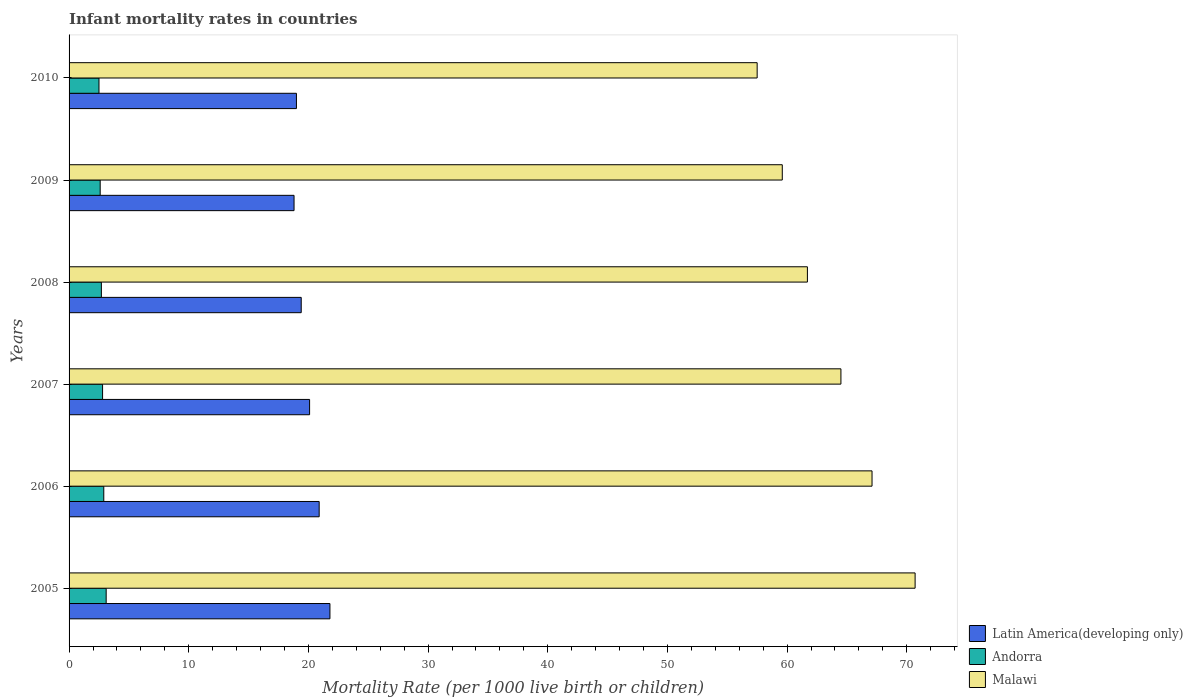Are the number of bars per tick equal to the number of legend labels?
Offer a terse response. Yes. How many bars are there on the 2nd tick from the top?
Your answer should be compact. 3. What is the label of the 5th group of bars from the top?
Offer a terse response. 2006. Across all years, what is the maximum infant mortality rate in Malawi?
Keep it short and to the point. 70.7. Across all years, what is the minimum infant mortality rate in Malawi?
Keep it short and to the point. 57.5. In which year was the infant mortality rate in Latin America(developing only) maximum?
Keep it short and to the point. 2005. In which year was the infant mortality rate in Malawi minimum?
Ensure brevity in your answer.  2010. What is the total infant mortality rate in Latin America(developing only) in the graph?
Your response must be concise. 120. What is the difference between the infant mortality rate in Malawi in 2006 and that in 2008?
Ensure brevity in your answer.  5.4. What is the difference between the infant mortality rate in Latin America(developing only) in 2006 and the infant mortality rate in Andorra in 2010?
Your response must be concise. 18.4. What is the average infant mortality rate in Malawi per year?
Your response must be concise. 63.52. In the year 2005, what is the difference between the infant mortality rate in Latin America(developing only) and infant mortality rate in Andorra?
Offer a very short reply. 18.7. Is the infant mortality rate in Andorra in 2007 less than that in 2009?
Your response must be concise. No. Is the difference between the infant mortality rate in Latin America(developing only) in 2005 and 2007 greater than the difference between the infant mortality rate in Andorra in 2005 and 2007?
Your answer should be compact. Yes. What is the difference between the highest and the second highest infant mortality rate in Latin America(developing only)?
Ensure brevity in your answer.  0.9. What is the difference between the highest and the lowest infant mortality rate in Malawi?
Provide a short and direct response. 13.2. Is the sum of the infant mortality rate in Malawi in 2006 and 2007 greater than the maximum infant mortality rate in Latin America(developing only) across all years?
Ensure brevity in your answer.  Yes. What does the 3rd bar from the top in 2005 represents?
Keep it short and to the point. Latin America(developing only). What does the 3rd bar from the bottom in 2010 represents?
Your answer should be very brief. Malawi. How many bars are there?
Your answer should be very brief. 18. Are all the bars in the graph horizontal?
Offer a very short reply. Yes. How many years are there in the graph?
Offer a very short reply. 6. Where does the legend appear in the graph?
Provide a succinct answer. Bottom right. How are the legend labels stacked?
Ensure brevity in your answer.  Vertical. What is the title of the graph?
Give a very brief answer. Infant mortality rates in countries. What is the label or title of the X-axis?
Offer a very short reply. Mortality Rate (per 1000 live birth or children). What is the label or title of the Y-axis?
Your response must be concise. Years. What is the Mortality Rate (per 1000 live birth or children) in Latin America(developing only) in 2005?
Make the answer very short. 21.8. What is the Mortality Rate (per 1000 live birth or children) in Andorra in 2005?
Keep it short and to the point. 3.1. What is the Mortality Rate (per 1000 live birth or children) of Malawi in 2005?
Ensure brevity in your answer.  70.7. What is the Mortality Rate (per 1000 live birth or children) of Latin America(developing only) in 2006?
Your answer should be very brief. 20.9. What is the Mortality Rate (per 1000 live birth or children) of Andorra in 2006?
Ensure brevity in your answer.  2.9. What is the Mortality Rate (per 1000 live birth or children) of Malawi in 2006?
Provide a succinct answer. 67.1. What is the Mortality Rate (per 1000 live birth or children) in Latin America(developing only) in 2007?
Provide a succinct answer. 20.1. What is the Mortality Rate (per 1000 live birth or children) of Andorra in 2007?
Your answer should be compact. 2.8. What is the Mortality Rate (per 1000 live birth or children) in Malawi in 2007?
Your answer should be very brief. 64.5. What is the Mortality Rate (per 1000 live birth or children) in Malawi in 2008?
Offer a very short reply. 61.7. What is the Mortality Rate (per 1000 live birth or children) in Latin America(developing only) in 2009?
Provide a succinct answer. 18.8. What is the Mortality Rate (per 1000 live birth or children) in Malawi in 2009?
Give a very brief answer. 59.6. What is the Mortality Rate (per 1000 live birth or children) in Latin America(developing only) in 2010?
Offer a terse response. 19. What is the Mortality Rate (per 1000 live birth or children) in Malawi in 2010?
Provide a short and direct response. 57.5. Across all years, what is the maximum Mortality Rate (per 1000 live birth or children) of Latin America(developing only)?
Provide a succinct answer. 21.8. Across all years, what is the maximum Mortality Rate (per 1000 live birth or children) in Malawi?
Give a very brief answer. 70.7. Across all years, what is the minimum Mortality Rate (per 1000 live birth or children) of Malawi?
Your answer should be very brief. 57.5. What is the total Mortality Rate (per 1000 live birth or children) in Latin America(developing only) in the graph?
Your answer should be compact. 120. What is the total Mortality Rate (per 1000 live birth or children) of Malawi in the graph?
Provide a short and direct response. 381.1. What is the difference between the Mortality Rate (per 1000 live birth or children) of Andorra in 2005 and that in 2008?
Your response must be concise. 0.4. What is the difference between the Mortality Rate (per 1000 live birth or children) in Andorra in 2005 and that in 2009?
Provide a short and direct response. 0.5. What is the difference between the Mortality Rate (per 1000 live birth or children) of Malawi in 2005 and that in 2009?
Provide a succinct answer. 11.1. What is the difference between the Mortality Rate (per 1000 live birth or children) of Latin America(developing only) in 2005 and that in 2010?
Provide a short and direct response. 2.8. What is the difference between the Mortality Rate (per 1000 live birth or children) in Latin America(developing only) in 2006 and that in 2007?
Ensure brevity in your answer.  0.8. What is the difference between the Mortality Rate (per 1000 live birth or children) in Malawi in 2006 and that in 2007?
Your answer should be very brief. 2.6. What is the difference between the Mortality Rate (per 1000 live birth or children) of Andorra in 2006 and that in 2009?
Your response must be concise. 0.3. What is the difference between the Mortality Rate (per 1000 live birth or children) of Malawi in 2006 and that in 2010?
Give a very brief answer. 9.6. What is the difference between the Mortality Rate (per 1000 live birth or children) of Latin America(developing only) in 2007 and that in 2008?
Offer a terse response. 0.7. What is the difference between the Mortality Rate (per 1000 live birth or children) in Andorra in 2007 and that in 2008?
Your answer should be very brief. 0.1. What is the difference between the Mortality Rate (per 1000 live birth or children) of Malawi in 2007 and that in 2008?
Your response must be concise. 2.8. What is the difference between the Mortality Rate (per 1000 live birth or children) in Latin America(developing only) in 2007 and that in 2009?
Provide a short and direct response. 1.3. What is the difference between the Mortality Rate (per 1000 live birth or children) of Andorra in 2007 and that in 2009?
Make the answer very short. 0.2. What is the difference between the Mortality Rate (per 1000 live birth or children) in Latin America(developing only) in 2008 and that in 2009?
Offer a terse response. 0.6. What is the difference between the Mortality Rate (per 1000 live birth or children) of Latin America(developing only) in 2008 and that in 2010?
Ensure brevity in your answer.  0.4. What is the difference between the Mortality Rate (per 1000 live birth or children) of Andorra in 2008 and that in 2010?
Offer a terse response. 0.2. What is the difference between the Mortality Rate (per 1000 live birth or children) in Malawi in 2008 and that in 2010?
Your answer should be compact. 4.2. What is the difference between the Mortality Rate (per 1000 live birth or children) in Latin America(developing only) in 2009 and that in 2010?
Make the answer very short. -0.2. What is the difference between the Mortality Rate (per 1000 live birth or children) in Andorra in 2009 and that in 2010?
Your response must be concise. 0.1. What is the difference between the Mortality Rate (per 1000 live birth or children) of Latin America(developing only) in 2005 and the Mortality Rate (per 1000 live birth or children) of Malawi in 2006?
Ensure brevity in your answer.  -45.3. What is the difference between the Mortality Rate (per 1000 live birth or children) of Andorra in 2005 and the Mortality Rate (per 1000 live birth or children) of Malawi in 2006?
Ensure brevity in your answer.  -64. What is the difference between the Mortality Rate (per 1000 live birth or children) in Latin America(developing only) in 2005 and the Mortality Rate (per 1000 live birth or children) in Andorra in 2007?
Your answer should be very brief. 19. What is the difference between the Mortality Rate (per 1000 live birth or children) in Latin America(developing only) in 2005 and the Mortality Rate (per 1000 live birth or children) in Malawi in 2007?
Ensure brevity in your answer.  -42.7. What is the difference between the Mortality Rate (per 1000 live birth or children) of Andorra in 2005 and the Mortality Rate (per 1000 live birth or children) of Malawi in 2007?
Your response must be concise. -61.4. What is the difference between the Mortality Rate (per 1000 live birth or children) in Latin America(developing only) in 2005 and the Mortality Rate (per 1000 live birth or children) in Andorra in 2008?
Your answer should be compact. 19.1. What is the difference between the Mortality Rate (per 1000 live birth or children) in Latin America(developing only) in 2005 and the Mortality Rate (per 1000 live birth or children) in Malawi in 2008?
Provide a succinct answer. -39.9. What is the difference between the Mortality Rate (per 1000 live birth or children) of Andorra in 2005 and the Mortality Rate (per 1000 live birth or children) of Malawi in 2008?
Your answer should be compact. -58.6. What is the difference between the Mortality Rate (per 1000 live birth or children) of Latin America(developing only) in 2005 and the Mortality Rate (per 1000 live birth or children) of Malawi in 2009?
Ensure brevity in your answer.  -37.8. What is the difference between the Mortality Rate (per 1000 live birth or children) in Andorra in 2005 and the Mortality Rate (per 1000 live birth or children) in Malawi in 2009?
Your response must be concise. -56.5. What is the difference between the Mortality Rate (per 1000 live birth or children) of Latin America(developing only) in 2005 and the Mortality Rate (per 1000 live birth or children) of Andorra in 2010?
Give a very brief answer. 19.3. What is the difference between the Mortality Rate (per 1000 live birth or children) in Latin America(developing only) in 2005 and the Mortality Rate (per 1000 live birth or children) in Malawi in 2010?
Give a very brief answer. -35.7. What is the difference between the Mortality Rate (per 1000 live birth or children) in Andorra in 2005 and the Mortality Rate (per 1000 live birth or children) in Malawi in 2010?
Your answer should be very brief. -54.4. What is the difference between the Mortality Rate (per 1000 live birth or children) in Latin America(developing only) in 2006 and the Mortality Rate (per 1000 live birth or children) in Malawi in 2007?
Keep it short and to the point. -43.6. What is the difference between the Mortality Rate (per 1000 live birth or children) in Andorra in 2006 and the Mortality Rate (per 1000 live birth or children) in Malawi in 2007?
Give a very brief answer. -61.6. What is the difference between the Mortality Rate (per 1000 live birth or children) of Latin America(developing only) in 2006 and the Mortality Rate (per 1000 live birth or children) of Andorra in 2008?
Your answer should be very brief. 18.2. What is the difference between the Mortality Rate (per 1000 live birth or children) in Latin America(developing only) in 2006 and the Mortality Rate (per 1000 live birth or children) in Malawi in 2008?
Provide a short and direct response. -40.8. What is the difference between the Mortality Rate (per 1000 live birth or children) in Andorra in 2006 and the Mortality Rate (per 1000 live birth or children) in Malawi in 2008?
Your response must be concise. -58.8. What is the difference between the Mortality Rate (per 1000 live birth or children) in Latin America(developing only) in 2006 and the Mortality Rate (per 1000 live birth or children) in Andorra in 2009?
Ensure brevity in your answer.  18.3. What is the difference between the Mortality Rate (per 1000 live birth or children) of Latin America(developing only) in 2006 and the Mortality Rate (per 1000 live birth or children) of Malawi in 2009?
Provide a succinct answer. -38.7. What is the difference between the Mortality Rate (per 1000 live birth or children) of Andorra in 2006 and the Mortality Rate (per 1000 live birth or children) of Malawi in 2009?
Offer a very short reply. -56.7. What is the difference between the Mortality Rate (per 1000 live birth or children) in Latin America(developing only) in 2006 and the Mortality Rate (per 1000 live birth or children) in Andorra in 2010?
Keep it short and to the point. 18.4. What is the difference between the Mortality Rate (per 1000 live birth or children) of Latin America(developing only) in 2006 and the Mortality Rate (per 1000 live birth or children) of Malawi in 2010?
Your response must be concise. -36.6. What is the difference between the Mortality Rate (per 1000 live birth or children) in Andorra in 2006 and the Mortality Rate (per 1000 live birth or children) in Malawi in 2010?
Keep it short and to the point. -54.6. What is the difference between the Mortality Rate (per 1000 live birth or children) of Latin America(developing only) in 2007 and the Mortality Rate (per 1000 live birth or children) of Malawi in 2008?
Offer a very short reply. -41.6. What is the difference between the Mortality Rate (per 1000 live birth or children) in Andorra in 2007 and the Mortality Rate (per 1000 live birth or children) in Malawi in 2008?
Make the answer very short. -58.9. What is the difference between the Mortality Rate (per 1000 live birth or children) of Latin America(developing only) in 2007 and the Mortality Rate (per 1000 live birth or children) of Malawi in 2009?
Your answer should be very brief. -39.5. What is the difference between the Mortality Rate (per 1000 live birth or children) of Andorra in 2007 and the Mortality Rate (per 1000 live birth or children) of Malawi in 2009?
Give a very brief answer. -56.8. What is the difference between the Mortality Rate (per 1000 live birth or children) of Latin America(developing only) in 2007 and the Mortality Rate (per 1000 live birth or children) of Malawi in 2010?
Your response must be concise. -37.4. What is the difference between the Mortality Rate (per 1000 live birth or children) of Andorra in 2007 and the Mortality Rate (per 1000 live birth or children) of Malawi in 2010?
Make the answer very short. -54.7. What is the difference between the Mortality Rate (per 1000 live birth or children) of Latin America(developing only) in 2008 and the Mortality Rate (per 1000 live birth or children) of Andorra in 2009?
Your answer should be compact. 16.8. What is the difference between the Mortality Rate (per 1000 live birth or children) of Latin America(developing only) in 2008 and the Mortality Rate (per 1000 live birth or children) of Malawi in 2009?
Your answer should be very brief. -40.2. What is the difference between the Mortality Rate (per 1000 live birth or children) in Andorra in 2008 and the Mortality Rate (per 1000 live birth or children) in Malawi in 2009?
Offer a very short reply. -56.9. What is the difference between the Mortality Rate (per 1000 live birth or children) in Latin America(developing only) in 2008 and the Mortality Rate (per 1000 live birth or children) in Andorra in 2010?
Your answer should be very brief. 16.9. What is the difference between the Mortality Rate (per 1000 live birth or children) in Latin America(developing only) in 2008 and the Mortality Rate (per 1000 live birth or children) in Malawi in 2010?
Provide a succinct answer. -38.1. What is the difference between the Mortality Rate (per 1000 live birth or children) in Andorra in 2008 and the Mortality Rate (per 1000 live birth or children) in Malawi in 2010?
Ensure brevity in your answer.  -54.8. What is the difference between the Mortality Rate (per 1000 live birth or children) of Latin America(developing only) in 2009 and the Mortality Rate (per 1000 live birth or children) of Andorra in 2010?
Your answer should be compact. 16.3. What is the difference between the Mortality Rate (per 1000 live birth or children) in Latin America(developing only) in 2009 and the Mortality Rate (per 1000 live birth or children) in Malawi in 2010?
Ensure brevity in your answer.  -38.7. What is the difference between the Mortality Rate (per 1000 live birth or children) of Andorra in 2009 and the Mortality Rate (per 1000 live birth or children) of Malawi in 2010?
Keep it short and to the point. -54.9. What is the average Mortality Rate (per 1000 live birth or children) of Latin America(developing only) per year?
Make the answer very short. 20. What is the average Mortality Rate (per 1000 live birth or children) in Andorra per year?
Make the answer very short. 2.77. What is the average Mortality Rate (per 1000 live birth or children) of Malawi per year?
Your response must be concise. 63.52. In the year 2005, what is the difference between the Mortality Rate (per 1000 live birth or children) of Latin America(developing only) and Mortality Rate (per 1000 live birth or children) of Malawi?
Your answer should be very brief. -48.9. In the year 2005, what is the difference between the Mortality Rate (per 1000 live birth or children) of Andorra and Mortality Rate (per 1000 live birth or children) of Malawi?
Your response must be concise. -67.6. In the year 2006, what is the difference between the Mortality Rate (per 1000 live birth or children) of Latin America(developing only) and Mortality Rate (per 1000 live birth or children) of Andorra?
Provide a succinct answer. 18. In the year 2006, what is the difference between the Mortality Rate (per 1000 live birth or children) in Latin America(developing only) and Mortality Rate (per 1000 live birth or children) in Malawi?
Your answer should be compact. -46.2. In the year 2006, what is the difference between the Mortality Rate (per 1000 live birth or children) in Andorra and Mortality Rate (per 1000 live birth or children) in Malawi?
Your answer should be very brief. -64.2. In the year 2007, what is the difference between the Mortality Rate (per 1000 live birth or children) in Latin America(developing only) and Mortality Rate (per 1000 live birth or children) in Malawi?
Give a very brief answer. -44.4. In the year 2007, what is the difference between the Mortality Rate (per 1000 live birth or children) in Andorra and Mortality Rate (per 1000 live birth or children) in Malawi?
Make the answer very short. -61.7. In the year 2008, what is the difference between the Mortality Rate (per 1000 live birth or children) in Latin America(developing only) and Mortality Rate (per 1000 live birth or children) in Malawi?
Make the answer very short. -42.3. In the year 2008, what is the difference between the Mortality Rate (per 1000 live birth or children) of Andorra and Mortality Rate (per 1000 live birth or children) of Malawi?
Offer a very short reply. -59. In the year 2009, what is the difference between the Mortality Rate (per 1000 live birth or children) in Latin America(developing only) and Mortality Rate (per 1000 live birth or children) in Malawi?
Keep it short and to the point. -40.8. In the year 2009, what is the difference between the Mortality Rate (per 1000 live birth or children) in Andorra and Mortality Rate (per 1000 live birth or children) in Malawi?
Your response must be concise. -57. In the year 2010, what is the difference between the Mortality Rate (per 1000 live birth or children) in Latin America(developing only) and Mortality Rate (per 1000 live birth or children) in Malawi?
Give a very brief answer. -38.5. In the year 2010, what is the difference between the Mortality Rate (per 1000 live birth or children) in Andorra and Mortality Rate (per 1000 live birth or children) in Malawi?
Your response must be concise. -55. What is the ratio of the Mortality Rate (per 1000 live birth or children) of Latin America(developing only) in 2005 to that in 2006?
Ensure brevity in your answer.  1.04. What is the ratio of the Mortality Rate (per 1000 live birth or children) in Andorra in 2005 to that in 2006?
Ensure brevity in your answer.  1.07. What is the ratio of the Mortality Rate (per 1000 live birth or children) in Malawi in 2005 to that in 2006?
Give a very brief answer. 1.05. What is the ratio of the Mortality Rate (per 1000 live birth or children) in Latin America(developing only) in 2005 to that in 2007?
Provide a succinct answer. 1.08. What is the ratio of the Mortality Rate (per 1000 live birth or children) in Andorra in 2005 to that in 2007?
Offer a terse response. 1.11. What is the ratio of the Mortality Rate (per 1000 live birth or children) of Malawi in 2005 to that in 2007?
Keep it short and to the point. 1.1. What is the ratio of the Mortality Rate (per 1000 live birth or children) of Latin America(developing only) in 2005 to that in 2008?
Your answer should be very brief. 1.12. What is the ratio of the Mortality Rate (per 1000 live birth or children) of Andorra in 2005 to that in 2008?
Your answer should be compact. 1.15. What is the ratio of the Mortality Rate (per 1000 live birth or children) of Malawi in 2005 to that in 2008?
Keep it short and to the point. 1.15. What is the ratio of the Mortality Rate (per 1000 live birth or children) of Latin America(developing only) in 2005 to that in 2009?
Provide a succinct answer. 1.16. What is the ratio of the Mortality Rate (per 1000 live birth or children) in Andorra in 2005 to that in 2009?
Give a very brief answer. 1.19. What is the ratio of the Mortality Rate (per 1000 live birth or children) of Malawi in 2005 to that in 2009?
Provide a short and direct response. 1.19. What is the ratio of the Mortality Rate (per 1000 live birth or children) in Latin America(developing only) in 2005 to that in 2010?
Your response must be concise. 1.15. What is the ratio of the Mortality Rate (per 1000 live birth or children) in Andorra in 2005 to that in 2010?
Make the answer very short. 1.24. What is the ratio of the Mortality Rate (per 1000 live birth or children) in Malawi in 2005 to that in 2010?
Provide a short and direct response. 1.23. What is the ratio of the Mortality Rate (per 1000 live birth or children) in Latin America(developing only) in 2006 to that in 2007?
Offer a very short reply. 1.04. What is the ratio of the Mortality Rate (per 1000 live birth or children) in Andorra in 2006 to that in 2007?
Make the answer very short. 1.04. What is the ratio of the Mortality Rate (per 1000 live birth or children) of Malawi in 2006 to that in 2007?
Offer a very short reply. 1.04. What is the ratio of the Mortality Rate (per 1000 live birth or children) of Latin America(developing only) in 2006 to that in 2008?
Provide a short and direct response. 1.08. What is the ratio of the Mortality Rate (per 1000 live birth or children) of Andorra in 2006 to that in 2008?
Your answer should be very brief. 1.07. What is the ratio of the Mortality Rate (per 1000 live birth or children) in Malawi in 2006 to that in 2008?
Give a very brief answer. 1.09. What is the ratio of the Mortality Rate (per 1000 live birth or children) in Latin America(developing only) in 2006 to that in 2009?
Ensure brevity in your answer.  1.11. What is the ratio of the Mortality Rate (per 1000 live birth or children) of Andorra in 2006 to that in 2009?
Your answer should be compact. 1.12. What is the ratio of the Mortality Rate (per 1000 live birth or children) of Malawi in 2006 to that in 2009?
Provide a succinct answer. 1.13. What is the ratio of the Mortality Rate (per 1000 live birth or children) of Andorra in 2006 to that in 2010?
Provide a succinct answer. 1.16. What is the ratio of the Mortality Rate (per 1000 live birth or children) of Malawi in 2006 to that in 2010?
Offer a very short reply. 1.17. What is the ratio of the Mortality Rate (per 1000 live birth or children) in Latin America(developing only) in 2007 to that in 2008?
Ensure brevity in your answer.  1.04. What is the ratio of the Mortality Rate (per 1000 live birth or children) in Malawi in 2007 to that in 2008?
Your answer should be very brief. 1.05. What is the ratio of the Mortality Rate (per 1000 live birth or children) in Latin America(developing only) in 2007 to that in 2009?
Ensure brevity in your answer.  1.07. What is the ratio of the Mortality Rate (per 1000 live birth or children) in Andorra in 2007 to that in 2009?
Ensure brevity in your answer.  1.08. What is the ratio of the Mortality Rate (per 1000 live birth or children) of Malawi in 2007 to that in 2009?
Your answer should be compact. 1.08. What is the ratio of the Mortality Rate (per 1000 live birth or children) of Latin America(developing only) in 2007 to that in 2010?
Your answer should be compact. 1.06. What is the ratio of the Mortality Rate (per 1000 live birth or children) of Andorra in 2007 to that in 2010?
Your answer should be very brief. 1.12. What is the ratio of the Mortality Rate (per 1000 live birth or children) in Malawi in 2007 to that in 2010?
Your response must be concise. 1.12. What is the ratio of the Mortality Rate (per 1000 live birth or children) in Latin America(developing only) in 2008 to that in 2009?
Provide a succinct answer. 1.03. What is the ratio of the Mortality Rate (per 1000 live birth or children) of Andorra in 2008 to that in 2009?
Keep it short and to the point. 1.04. What is the ratio of the Mortality Rate (per 1000 live birth or children) of Malawi in 2008 to that in 2009?
Give a very brief answer. 1.04. What is the ratio of the Mortality Rate (per 1000 live birth or children) of Latin America(developing only) in 2008 to that in 2010?
Provide a succinct answer. 1.02. What is the ratio of the Mortality Rate (per 1000 live birth or children) of Malawi in 2008 to that in 2010?
Offer a very short reply. 1.07. What is the ratio of the Mortality Rate (per 1000 live birth or children) of Latin America(developing only) in 2009 to that in 2010?
Your answer should be very brief. 0.99. What is the ratio of the Mortality Rate (per 1000 live birth or children) in Malawi in 2009 to that in 2010?
Offer a terse response. 1.04. What is the difference between the highest and the second highest Mortality Rate (per 1000 live birth or children) in Latin America(developing only)?
Ensure brevity in your answer.  0.9. What is the difference between the highest and the lowest Mortality Rate (per 1000 live birth or children) in Latin America(developing only)?
Provide a short and direct response. 3. What is the difference between the highest and the lowest Mortality Rate (per 1000 live birth or children) in Andorra?
Keep it short and to the point. 0.6. 